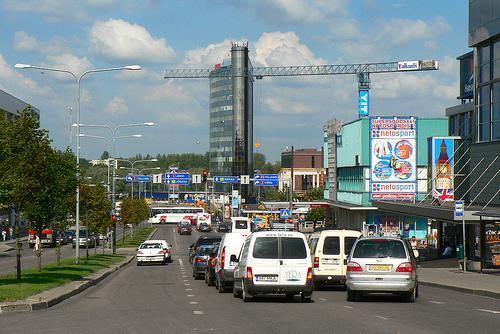How many cars are in the left lane?
Give a very brief answer. 2. 